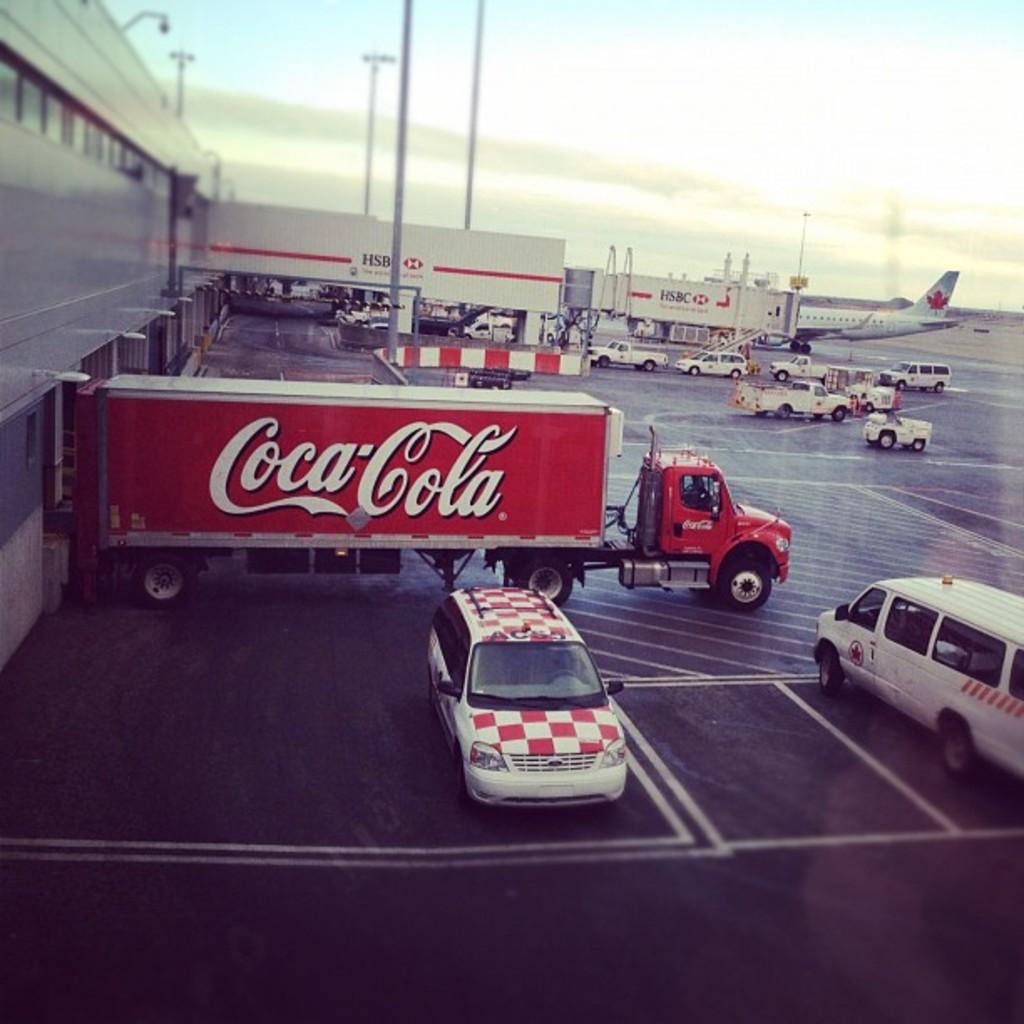What brand is on the truck?
Your answer should be compact. Coca cola. Coca cola hsbc?
Offer a terse response. Not a question. 